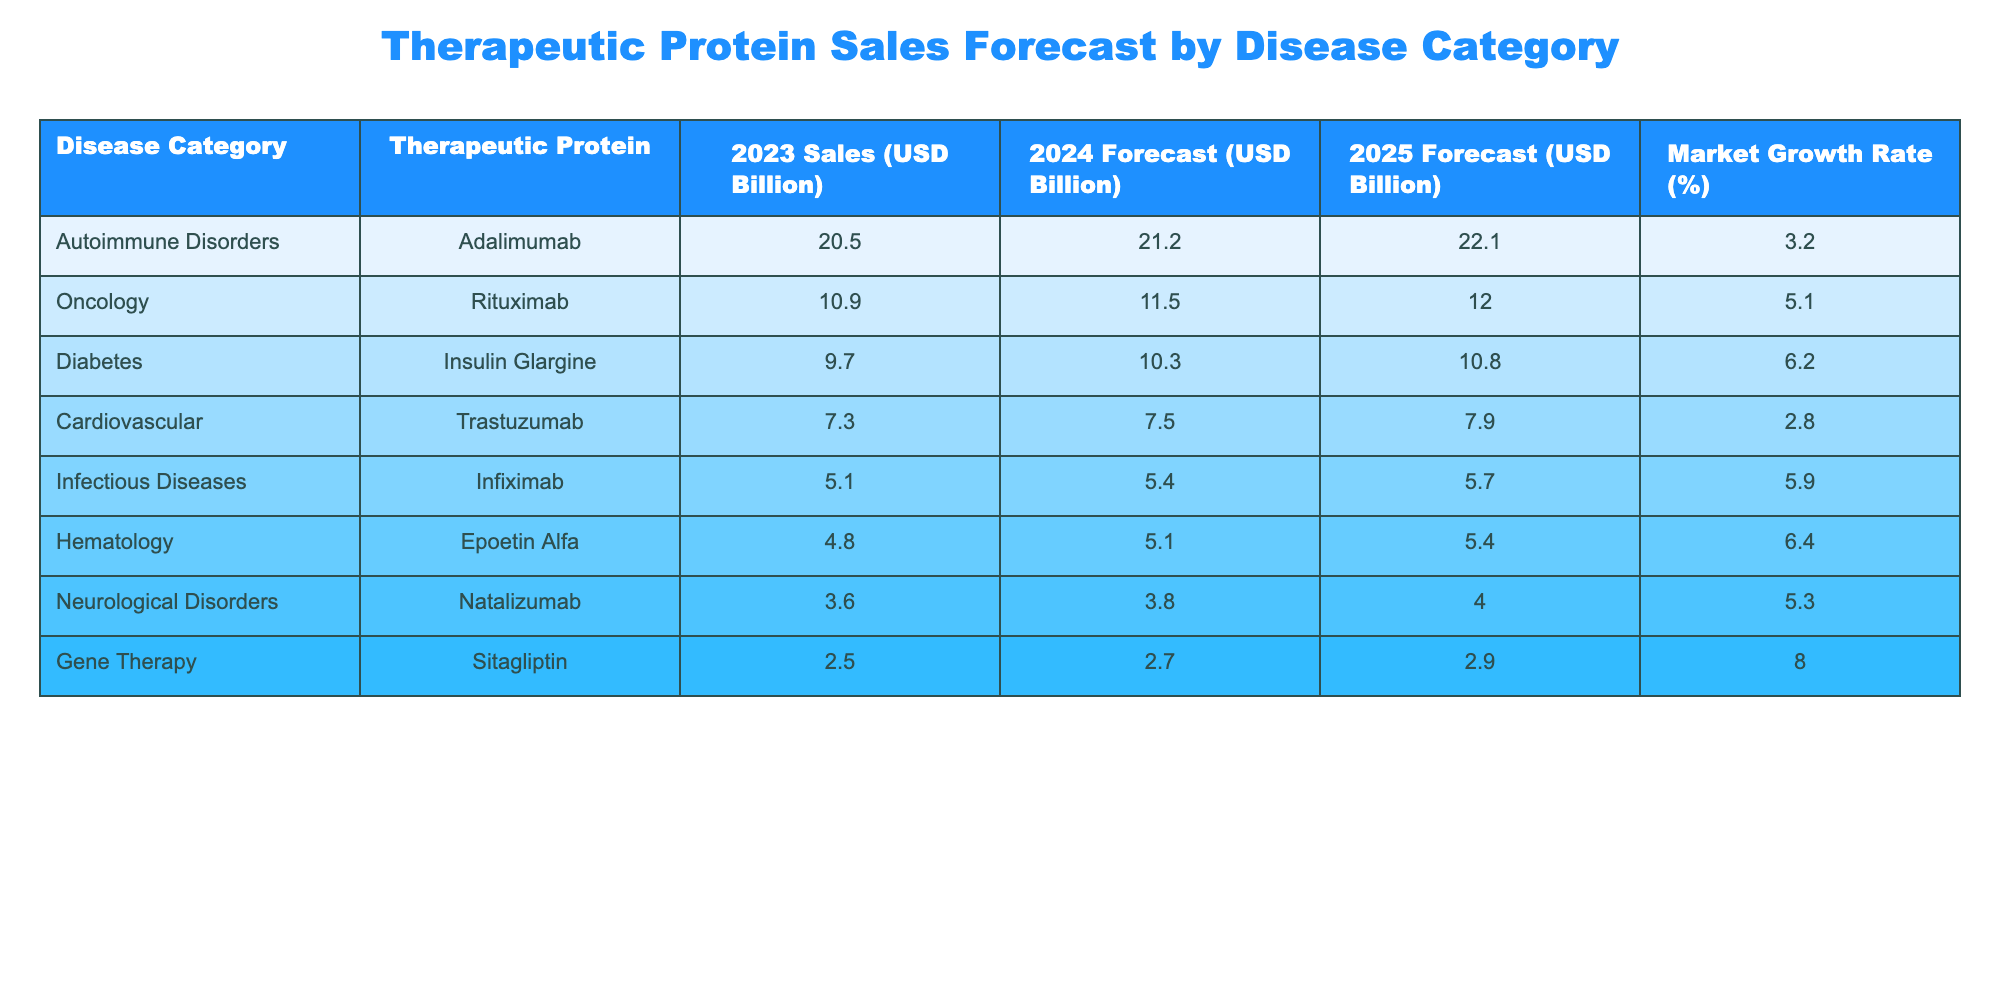What is the total sales of therapeutic proteins for Autoimmune Disorders in 2023? In the table, the sales for Autoimmune Disorders in 2023 are listed as 20.5 billion USD. Therefore, the total sales in this category for that year are simply that value.
Answer: 20.5 billion USD Which therapeutic protein has the highest forecast sales in 2025? By looking at the 2025 forecast column in the table, the therapeutic proteins with their respective sales forecasts are Adalimumab (22.1 billion), Rituximab (12.0 billion), Insulin Glargine (10.8 billion), and others. Adalimumab has the highest value of 22.1 billion USD, making it the protein with the highest forecast sales in 2025.
Answer: Adalimumab What is the average growth rate of all the therapeutic proteins in the table? The growth rates listed are 3.2, 5.1, 6.2, 2.8, 5.9, 6.4, 5.3, and 8.0. Adding these up gives 43.0 and dividing by the number of proteins, which is 8, gives an average of 5.375%.
Answer: 5.375% Is the market growth rate for neurological disorders higher than for cardiovascular disorders? The market growth rate for neurological disorders is 5.3%, while for cardiovascular disorders it is 2.8%. Since 5.3% is greater than 2.8%, it confirms that neurological disorders have a higher growth rate.
Answer: Yes Which disease category is expected to show the largest increase in sales from 2023 to 2024? To find this, we calculate the difference between forecast sales for 2024 and 2023 for each category. The differences are 0.7 (Autoimmune), 0.6 (Oncology), 0.6 (Diabetes), 0.2 (Cardiovascular), 0.3 (Infectious Diseases), 0.3 (Hematology), 0.2 (Neurological), and 0.2 (Gene Therapy). The largest increase is 0.7 billion USD for Autoimmune Disorders.
Answer: Autoimmune Disorders Which therapeutic protein has the lowest sales in 2023? Looking at the sales figures for 2023, the therapeutic proteins are listed as follows: Adalimumab (20.5), Rituximab (10.9), Insulin Glargine (9.7), Trastuzumab (7.3), Infiximab (5.1), Epoetin Alfa (4.8), Natalizumab (3.6), and Sitagliptin (2.5). The lowest sales are attributed to Sitagliptin at 2.5 billion USD.
Answer: Sitagliptin 